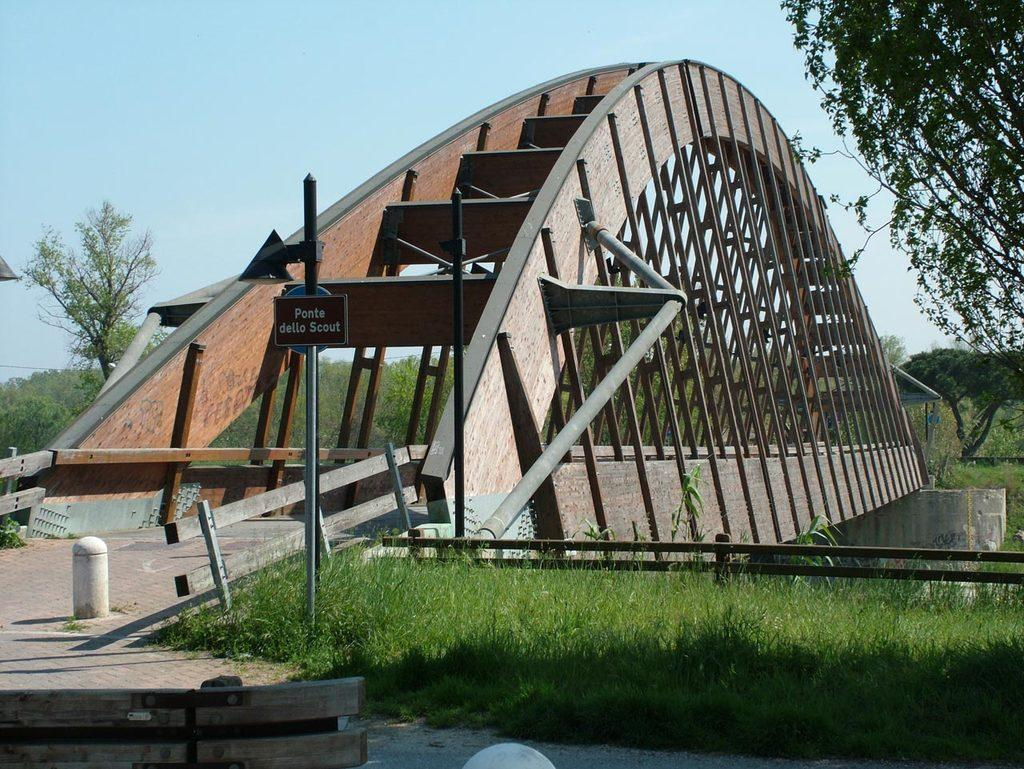What structure is present in the image? There is a bridge in the image. What type of vegetation can be seen on the right side of the image? There are plants in green color on the right side of the image. What is the color of the sky in the image? The sky is white in color at the top of the image. What scent can be detected from the plants in the image? There is no information about the scent of the plants in the image, as we are only given visual information. 